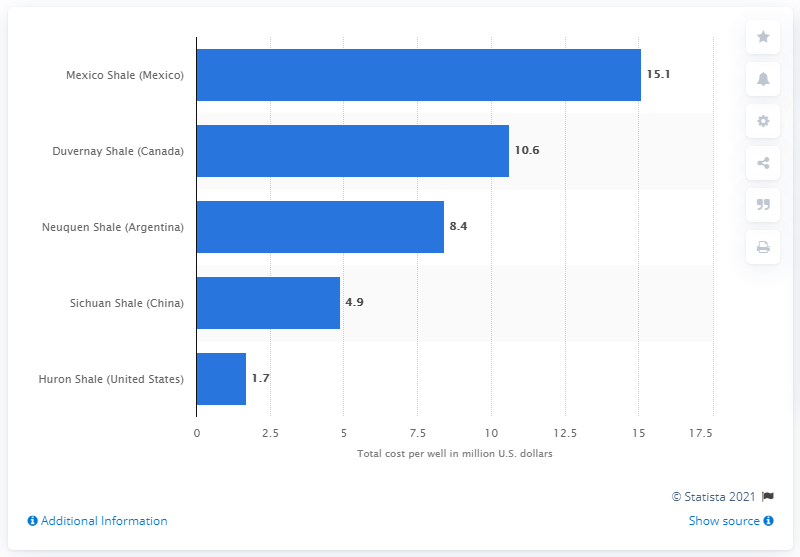Point out several critical features in this image. The fracking cost per well in Argentina's Neuquen Shale was 8.4. 